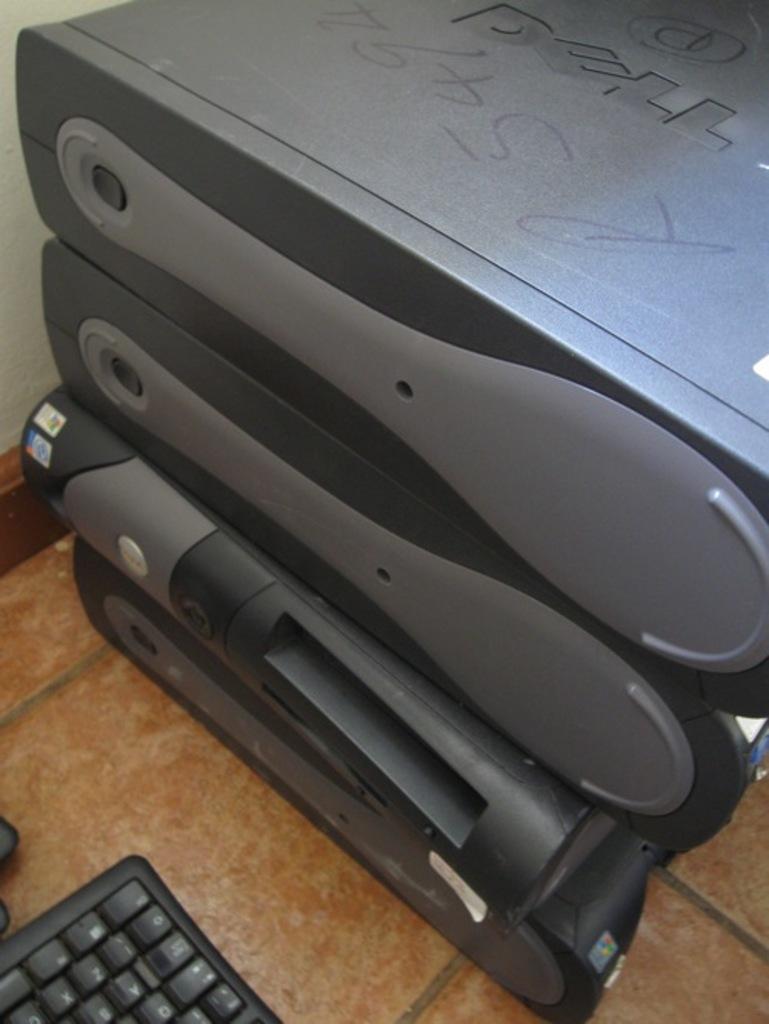Can you read any keys on the keyboard?
Make the answer very short. Yes. 